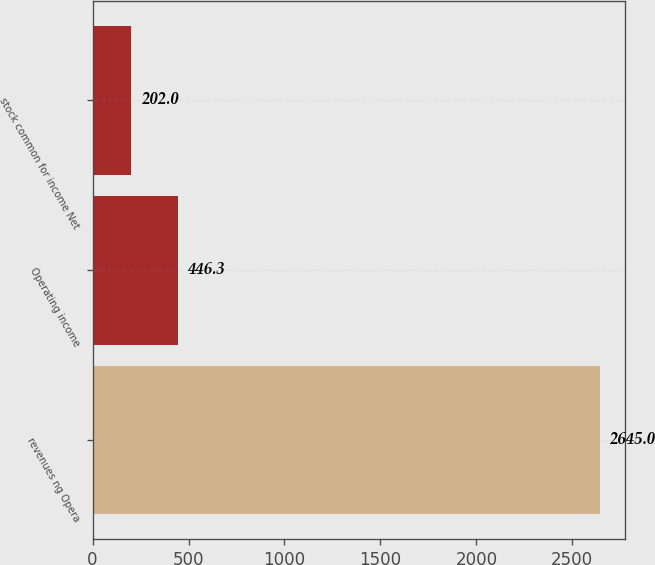<chart> <loc_0><loc_0><loc_500><loc_500><bar_chart><fcel>revenues ng Opera<fcel>Operating income<fcel>stock common for income Net<nl><fcel>2645<fcel>446.3<fcel>202<nl></chart> 